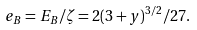Convert formula to latex. <formula><loc_0><loc_0><loc_500><loc_500>e _ { B } = E _ { B } / \zeta = 2 ( 3 + y ) ^ { 3 / 2 } / 2 7 .</formula> 